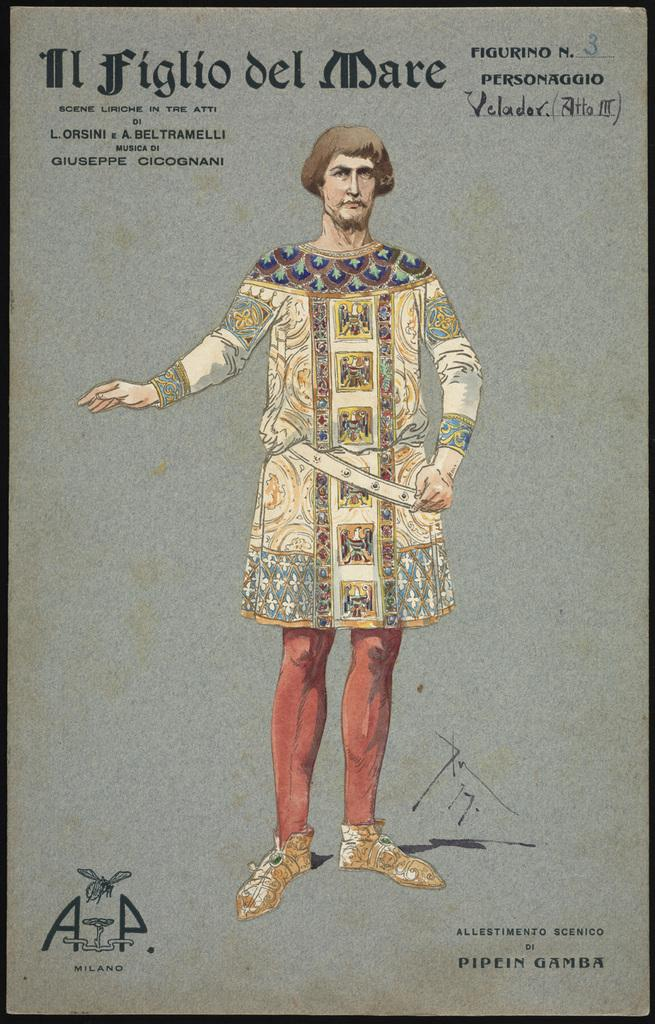What is the main subject of the image? There is a person in the image. What type of artwork is the image? The image is a painting. What type of car is the person driving in the painting? There is no car present in the painting; it only features a person. What book is the person reading in the painting? There is no book or reading depicted in the painting; it only features a person. 